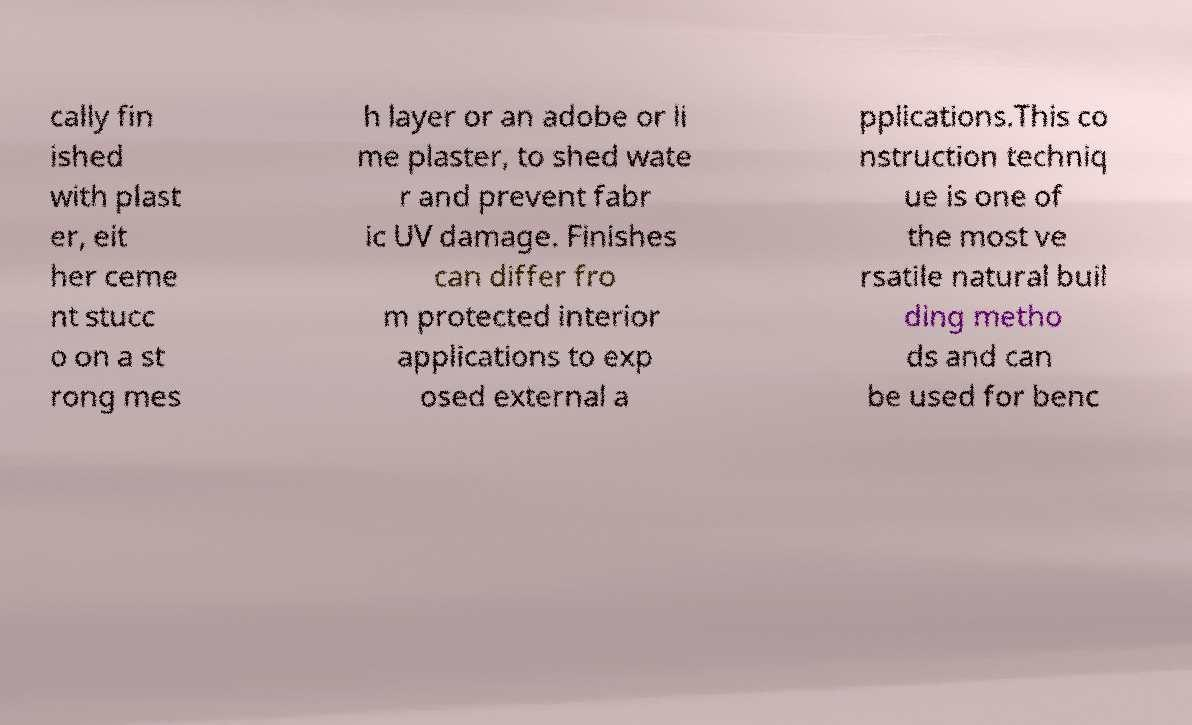What messages or text are displayed in this image? I need them in a readable, typed format. cally fin ished with plast er, eit her ceme nt stucc o on a st rong mes h layer or an adobe or li me plaster, to shed wate r and prevent fabr ic UV damage. Finishes can differ fro m protected interior applications to exp osed external a pplications.This co nstruction techniq ue is one of the most ve rsatile natural buil ding metho ds and can be used for benc 